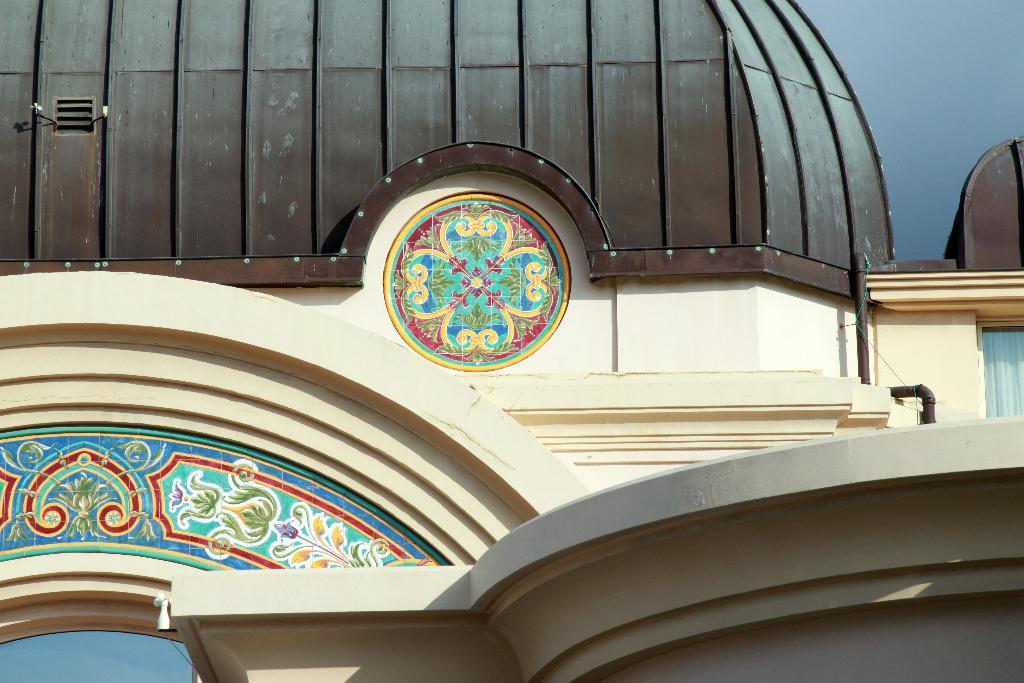How would you summarize this image in a sentence or two? This picture contains a building in white and brown color. In the middle of the picture, we see a sticker in different colors is pasted on the white wall. At the top of the picture, we see the roof of the building, which is in brown color. In the right top of the picture, we see the sky. On the right side, we see a curtain in white color. 